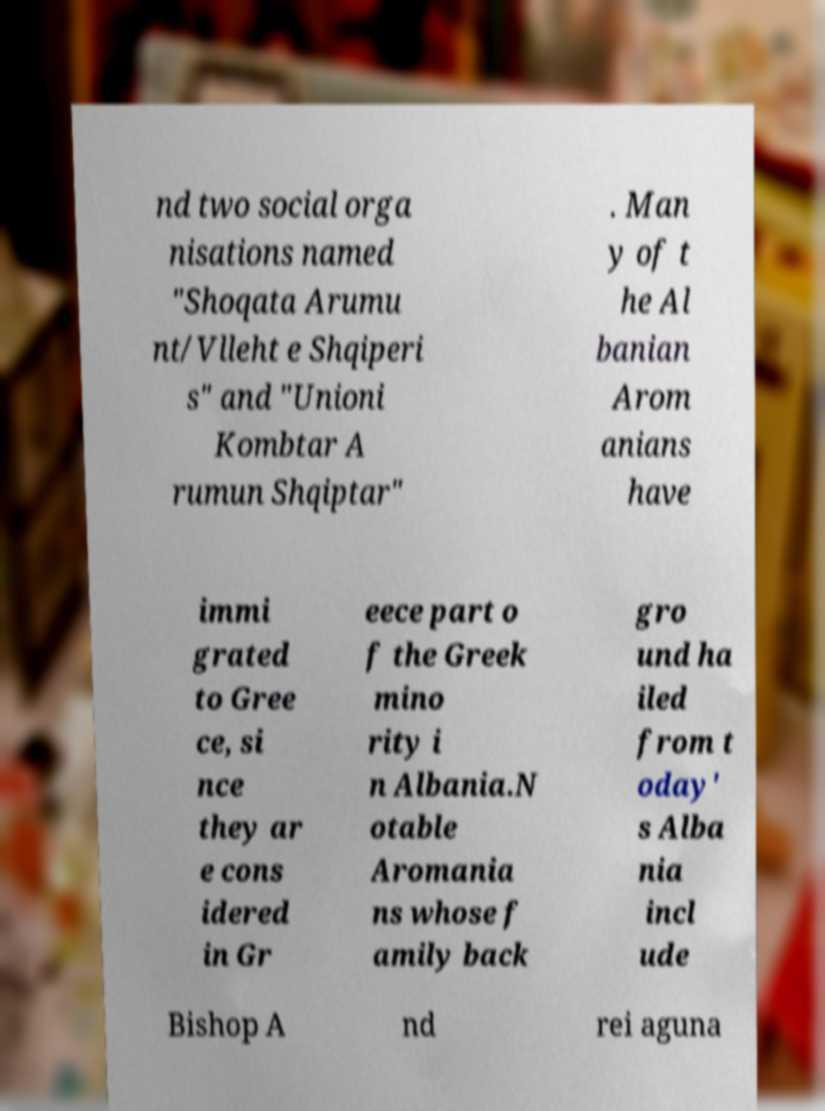There's text embedded in this image that I need extracted. Can you transcribe it verbatim? nd two social orga nisations named "Shoqata Arumu nt/Vlleht e Shqiperi s" and "Unioni Kombtar A rumun Shqiptar" . Man y of t he Al banian Arom anians have immi grated to Gree ce, si nce they ar e cons idered in Gr eece part o f the Greek mino rity i n Albania.N otable Aromania ns whose f amily back gro und ha iled from t oday' s Alba nia incl ude Bishop A nd rei aguna 